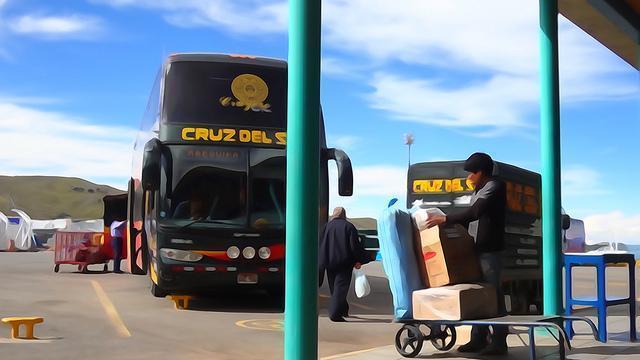How many buses are here?
Give a very brief answer. 2. How many buses are visible?
Give a very brief answer. 2. How many people are in the photo?
Give a very brief answer. 2. 